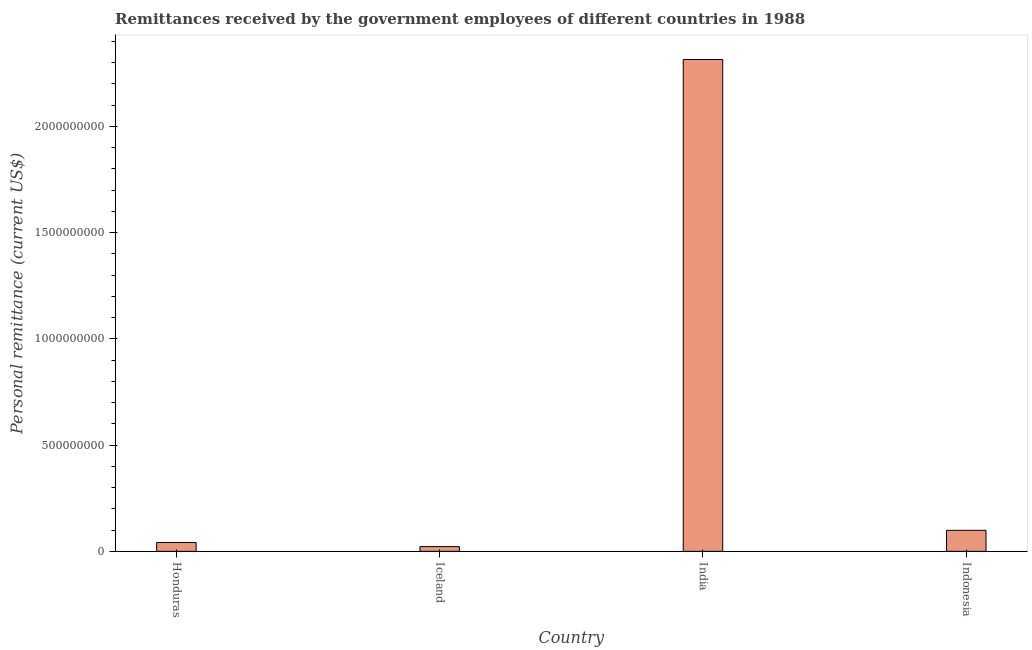Does the graph contain any zero values?
Make the answer very short. No. Does the graph contain grids?
Give a very brief answer. No. What is the title of the graph?
Your answer should be compact. Remittances received by the government employees of different countries in 1988. What is the label or title of the Y-axis?
Your answer should be compact. Personal remittance (current US$). What is the personal remittances in Iceland?
Provide a succinct answer. 2.24e+07. Across all countries, what is the maximum personal remittances?
Your answer should be compact. 2.32e+09. Across all countries, what is the minimum personal remittances?
Keep it short and to the point. 2.24e+07. What is the sum of the personal remittances?
Offer a very short reply. 2.48e+09. What is the difference between the personal remittances in Honduras and Indonesia?
Offer a very short reply. -5.72e+07. What is the average personal remittances per country?
Give a very brief answer. 6.20e+08. What is the median personal remittances?
Your answer should be very brief. 7.04e+07. What is the ratio of the personal remittances in Honduras to that in Indonesia?
Make the answer very short. 0.42. What is the difference between the highest and the second highest personal remittances?
Your answer should be compact. 2.22e+09. Is the sum of the personal remittances in Honduras and Iceland greater than the maximum personal remittances across all countries?
Offer a very short reply. No. What is the difference between the highest and the lowest personal remittances?
Your answer should be compact. 2.29e+09. In how many countries, is the personal remittances greater than the average personal remittances taken over all countries?
Provide a succinct answer. 1. Are the values on the major ticks of Y-axis written in scientific E-notation?
Ensure brevity in your answer.  No. What is the Personal remittance (current US$) of Honduras?
Offer a terse response. 4.18e+07. What is the Personal remittance (current US$) in Iceland?
Keep it short and to the point. 2.24e+07. What is the Personal remittance (current US$) of India?
Your answer should be compact. 2.32e+09. What is the Personal remittance (current US$) of Indonesia?
Provide a short and direct response. 9.90e+07. What is the difference between the Personal remittance (current US$) in Honduras and Iceland?
Your answer should be compact. 1.94e+07. What is the difference between the Personal remittance (current US$) in Honduras and India?
Give a very brief answer. -2.27e+09. What is the difference between the Personal remittance (current US$) in Honduras and Indonesia?
Provide a short and direct response. -5.72e+07. What is the difference between the Personal remittance (current US$) in Iceland and India?
Provide a short and direct response. -2.29e+09. What is the difference between the Personal remittance (current US$) in Iceland and Indonesia?
Your response must be concise. -7.66e+07. What is the difference between the Personal remittance (current US$) in India and Indonesia?
Your answer should be compact. 2.22e+09. What is the ratio of the Personal remittance (current US$) in Honduras to that in Iceland?
Offer a very short reply. 1.87. What is the ratio of the Personal remittance (current US$) in Honduras to that in India?
Your answer should be compact. 0.02. What is the ratio of the Personal remittance (current US$) in Honduras to that in Indonesia?
Give a very brief answer. 0.42. What is the ratio of the Personal remittance (current US$) in Iceland to that in Indonesia?
Your answer should be compact. 0.23. What is the ratio of the Personal remittance (current US$) in India to that in Indonesia?
Offer a very short reply. 23.39. 